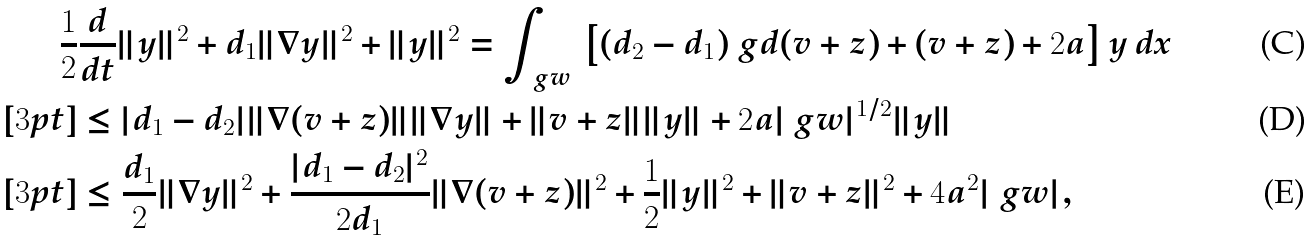Convert formula to latex. <formula><loc_0><loc_0><loc_500><loc_500>\frac { 1 } { 2 } & \frac { d } { d t } \| y \| ^ { 2 } + d _ { 1 } \| \nabla y \| ^ { 2 } + \| y \| ^ { 2 } = \int _ { \ g w } \, \left [ ( d _ { 2 } - d _ { 1 } ) \ g d ( v + z ) + ( v + z ) + 2 a \right ] y \, d x \\ [ 3 p t ] & \leq | d _ { 1 } - d _ { 2 } | \| \nabla ( v + z ) \| \| \nabla y \| + \| v + z \| \| y \| + 2 a | \ g w | ^ { 1 / 2 } \| y \| \\ [ 3 p t ] & \leq \frac { d _ { 1 } } { 2 } \| \nabla y \| ^ { 2 } + \frac { | d _ { 1 } - d _ { 2 } | ^ { 2 } } { 2 d _ { 1 } } \| \nabla ( v + z ) \| ^ { 2 } + \frac { 1 } { 2 } \| y \| ^ { 2 } + \| v + z \| ^ { 2 } + 4 a ^ { 2 } | \ g w | ,</formula> 